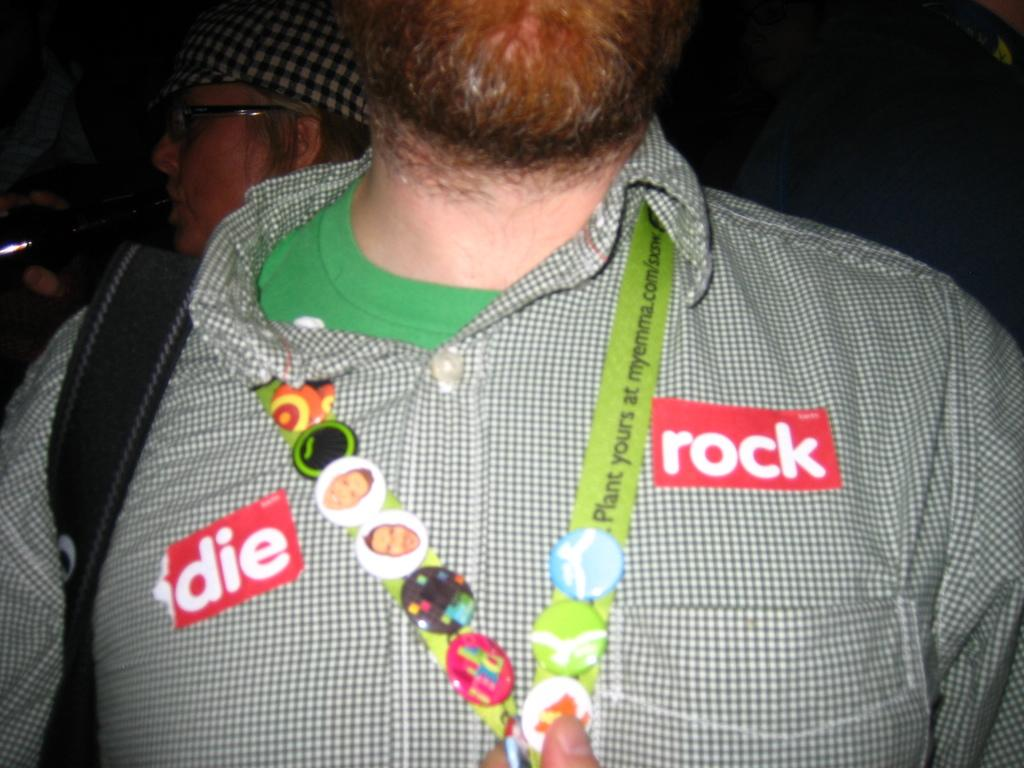Who is the main subject in the image? There is a person in the center of the image. What is the person wearing on their body? The person is wearing a bag and an ID card. Can you describe the background of the image? There is another person in the background of the image. What type of ray can be seen swimming in the water in the image? There is no ray or water present in the image; it features a person wearing a bag and an ID card. 